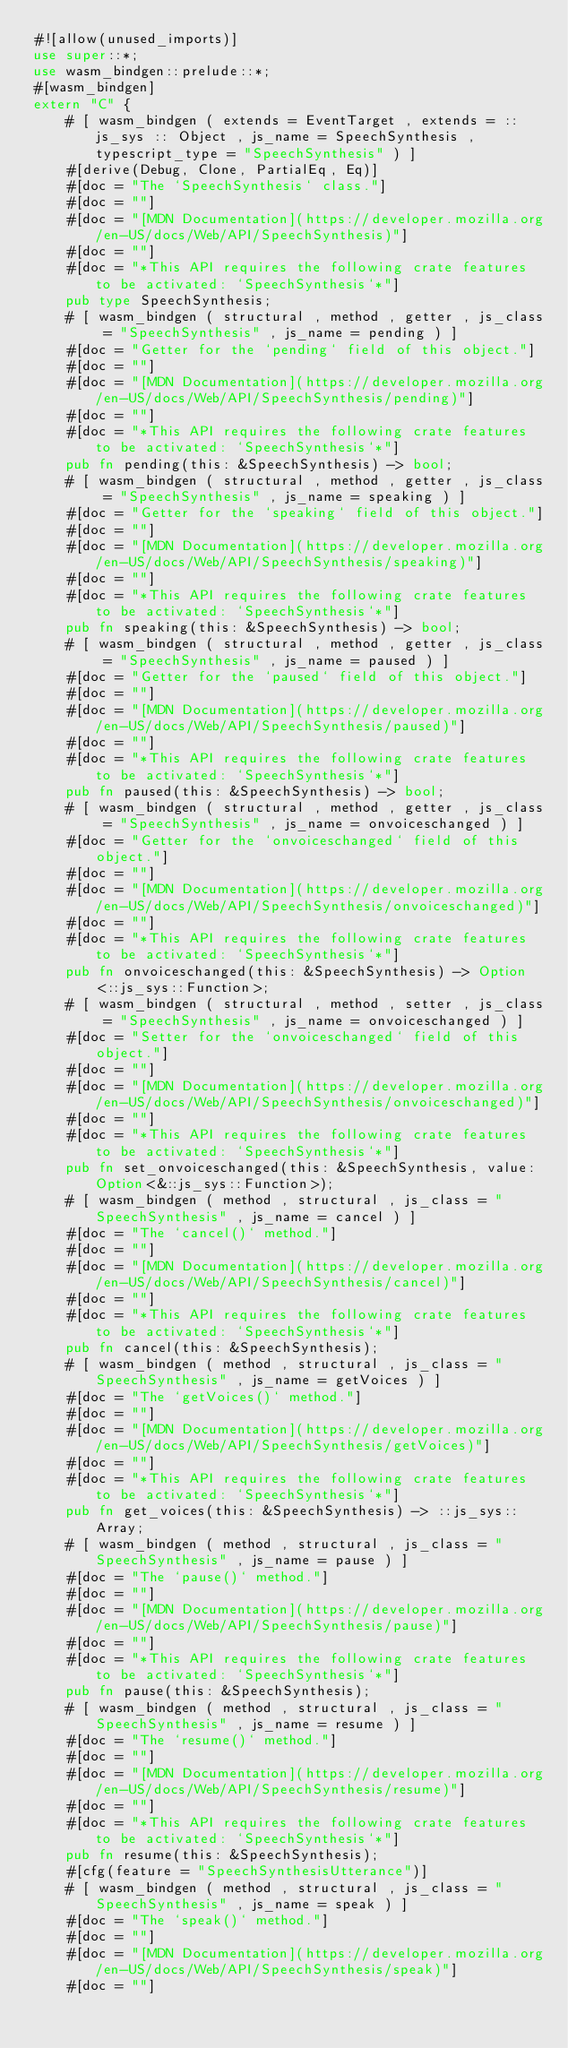Convert code to text. <code><loc_0><loc_0><loc_500><loc_500><_Rust_>#![allow(unused_imports)]
use super::*;
use wasm_bindgen::prelude::*;
#[wasm_bindgen]
extern "C" {
    # [ wasm_bindgen ( extends = EventTarget , extends = :: js_sys :: Object , js_name = SpeechSynthesis , typescript_type = "SpeechSynthesis" ) ]
    #[derive(Debug, Clone, PartialEq, Eq)]
    #[doc = "The `SpeechSynthesis` class."]
    #[doc = ""]
    #[doc = "[MDN Documentation](https://developer.mozilla.org/en-US/docs/Web/API/SpeechSynthesis)"]
    #[doc = ""]
    #[doc = "*This API requires the following crate features to be activated: `SpeechSynthesis`*"]
    pub type SpeechSynthesis;
    # [ wasm_bindgen ( structural , method , getter , js_class = "SpeechSynthesis" , js_name = pending ) ]
    #[doc = "Getter for the `pending` field of this object."]
    #[doc = ""]
    #[doc = "[MDN Documentation](https://developer.mozilla.org/en-US/docs/Web/API/SpeechSynthesis/pending)"]
    #[doc = ""]
    #[doc = "*This API requires the following crate features to be activated: `SpeechSynthesis`*"]
    pub fn pending(this: &SpeechSynthesis) -> bool;
    # [ wasm_bindgen ( structural , method , getter , js_class = "SpeechSynthesis" , js_name = speaking ) ]
    #[doc = "Getter for the `speaking` field of this object."]
    #[doc = ""]
    #[doc = "[MDN Documentation](https://developer.mozilla.org/en-US/docs/Web/API/SpeechSynthesis/speaking)"]
    #[doc = ""]
    #[doc = "*This API requires the following crate features to be activated: `SpeechSynthesis`*"]
    pub fn speaking(this: &SpeechSynthesis) -> bool;
    # [ wasm_bindgen ( structural , method , getter , js_class = "SpeechSynthesis" , js_name = paused ) ]
    #[doc = "Getter for the `paused` field of this object."]
    #[doc = ""]
    #[doc = "[MDN Documentation](https://developer.mozilla.org/en-US/docs/Web/API/SpeechSynthesis/paused)"]
    #[doc = ""]
    #[doc = "*This API requires the following crate features to be activated: `SpeechSynthesis`*"]
    pub fn paused(this: &SpeechSynthesis) -> bool;
    # [ wasm_bindgen ( structural , method , getter , js_class = "SpeechSynthesis" , js_name = onvoiceschanged ) ]
    #[doc = "Getter for the `onvoiceschanged` field of this object."]
    #[doc = ""]
    #[doc = "[MDN Documentation](https://developer.mozilla.org/en-US/docs/Web/API/SpeechSynthesis/onvoiceschanged)"]
    #[doc = ""]
    #[doc = "*This API requires the following crate features to be activated: `SpeechSynthesis`*"]
    pub fn onvoiceschanged(this: &SpeechSynthesis) -> Option<::js_sys::Function>;
    # [ wasm_bindgen ( structural , method , setter , js_class = "SpeechSynthesis" , js_name = onvoiceschanged ) ]
    #[doc = "Setter for the `onvoiceschanged` field of this object."]
    #[doc = ""]
    #[doc = "[MDN Documentation](https://developer.mozilla.org/en-US/docs/Web/API/SpeechSynthesis/onvoiceschanged)"]
    #[doc = ""]
    #[doc = "*This API requires the following crate features to be activated: `SpeechSynthesis`*"]
    pub fn set_onvoiceschanged(this: &SpeechSynthesis, value: Option<&::js_sys::Function>);
    # [ wasm_bindgen ( method , structural , js_class = "SpeechSynthesis" , js_name = cancel ) ]
    #[doc = "The `cancel()` method."]
    #[doc = ""]
    #[doc = "[MDN Documentation](https://developer.mozilla.org/en-US/docs/Web/API/SpeechSynthesis/cancel)"]
    #[doc = ""]
    #[doc = "*This API requires the following crate features to be activated: `SpeechSynthesis`*"]
    pub fn cancel(this: &SpeechSynthesis);
    # [ wasm_bindgen ( method , structural , js_class = "SpeechSynthesis" , js_name = getVoices ) ]
    #[doc = "The `getVoices()` method."]
    #[doc = ""]
    #[doc = "[MDN Documentation](https://developer.mozilla.org/en-US/docs/Web/API/SpeechSynthesis/getVoices)"]
    #[doc = ""]
    #[doc = "*This API requires the following crate features to be activated: `SpeechSynthesis`*"]
    pub fn get_voices(this: &SpeechSynthesis) -> ::js_sys::Array;
    # [ wasm_bindgen ( method , structural , js_class = "SpeechSynthesis" , js_name = pause ) ]
    #[doc = "The `pause()` method."]
    #[doc = ""]
    #[doc = "[MDN Documentation](https://developer.mozilla.org/en-US/docs/Web/API/SpeechSynthesis/pause)"]
    #[doc = ""]
    #[doc = "*This API requires the following crate features to be activated: `SpeechSynthesis`*"]
    pub fn pause(this: &SpeechSynthesis);
    # [ wasm_bindgen ( method , structural , js_class = "SpeechSynthesis" , js_name = resume ) ]
    #[doc = "The `resume()` method."]
    #[doc = ""]
    #[doc = "[MDN Documentation](https://developer.mozilla.org/en-US/docs/Web/API/SpeechSynthesis/resume)"]
    #[doc = ""]
    #[doc = "*This API requires the following crate features to be activated: `SpeechSynthesis`*"]
    pub fn resume(this: &SpeechSynthesis);
    #[cfg(feature = "SpeechSynthesisUtterance")]
    # [ wasm_bindgen ( method , structural , js_class = "SpeechSynthesis" , js_name = speak ) ]
    #[doc = "The `speak()` method."]
    #[doc = ""]
    #[doc = "[MDN Documentation](https://developer.mozilla.org/en-US/docs/Web/API/SpeechSynthesis/speak)"]
    #[doc = ""]</code> 